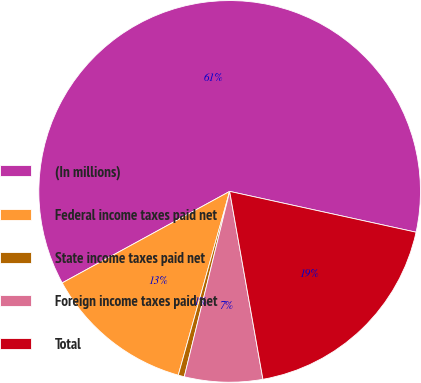Convert chart to OTSL. <chart><loc_0><loc_0><loc_500><loc_500><pie_chart><fcel>(In millions)<fcel>Federal income taxes paid net<fcel>State income taxes paid net<fcel>Foreign income taxes paid net<fcel>Total<nl><fcel>61.39%<fcel>12.7%<fcel>0.52%<fcel>6.61%<fcel>18.78%<nl></chart> 